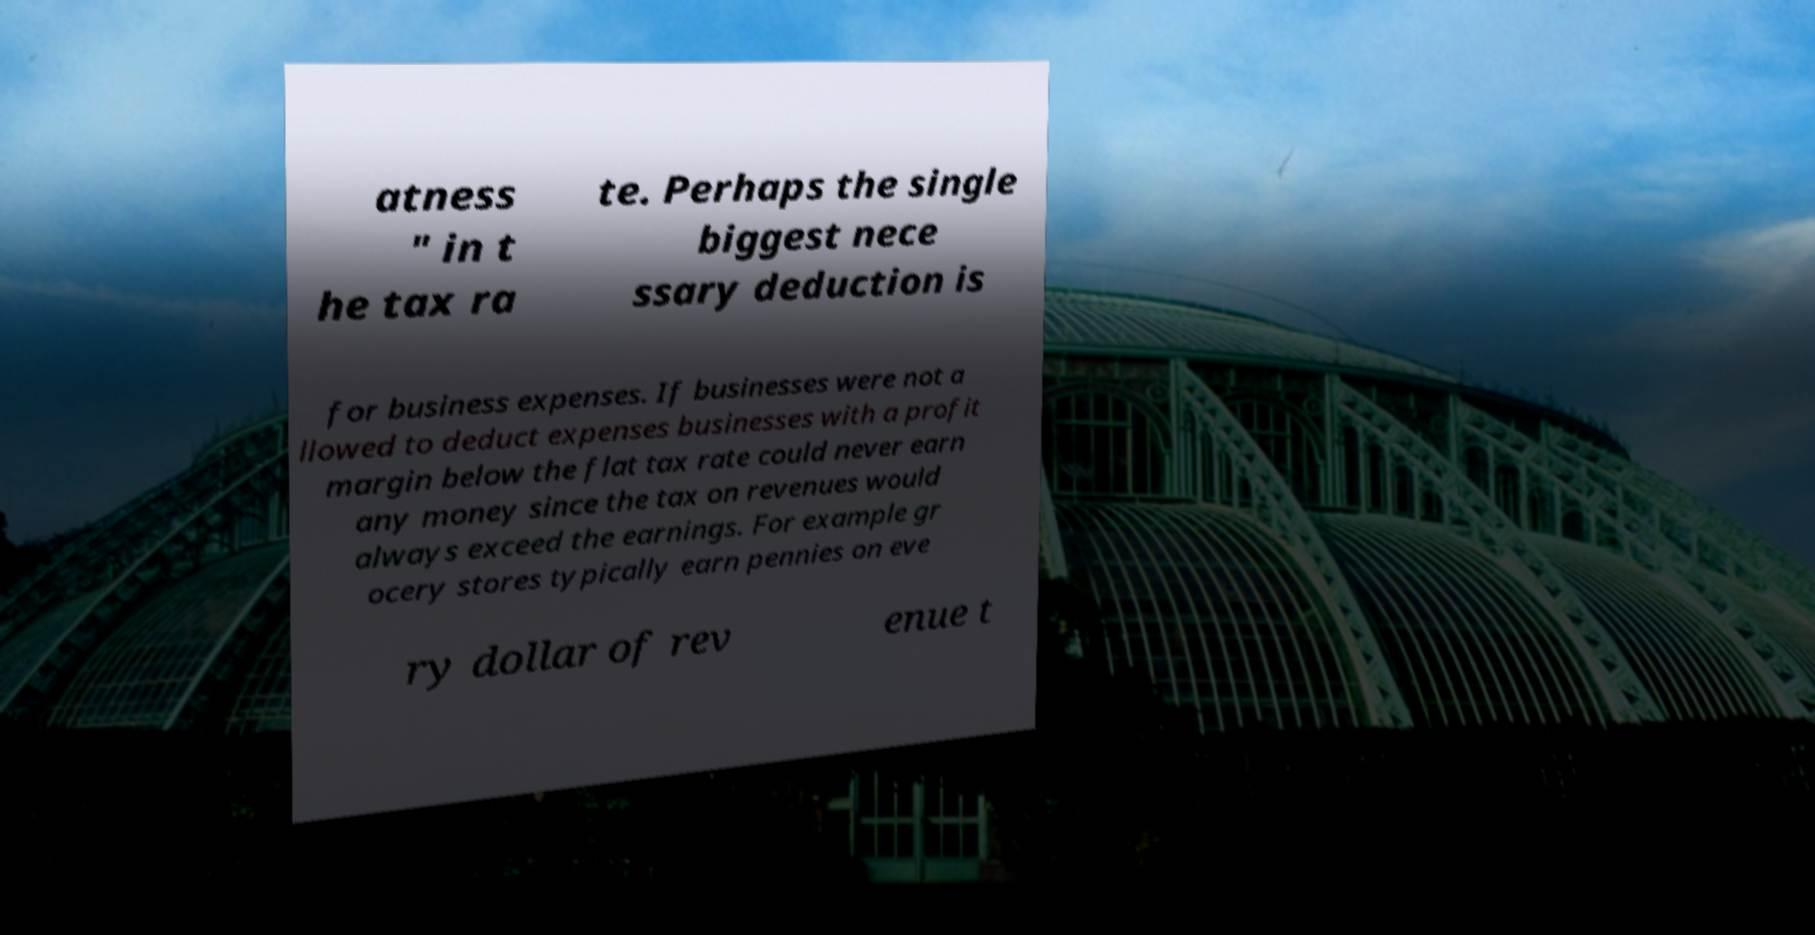Can you accurately transcribe the text from the provided image for me? atness " in t he tax ra te. Perhaps the single biggest nece ssary deduction is for business expenses. If businesses were not a llowed to deduct expenses businesses with a profit margin below the flat tax rate could never earn any money since the tax on revenues would always exceed the earnings. For example gr ocery stores typically earn pennies on eve ry dollar of rev enue t 